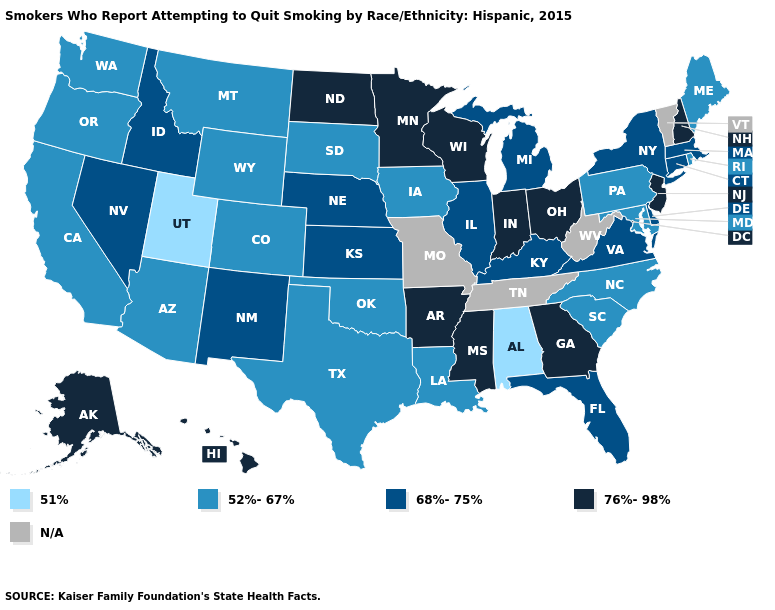What is the lowest value in the USA?
Concise answer only. 51%. What is the lowest value in the MidWest?
Concise answer only. 52%-67%. Does Connecticut have the highest value in the USA?
Quick response, please. No. What is the highest value in the West ?
Give a very brief answer. 76%-98%. What is the value of Rhode Island?
Give a very brief answer. 52%-67%. How many symbols are there in the legend?
Keep it brief. 5. How many symbols are there in the legend?
Short answer required. 5. What is the highest value in the Northeast ?
Be succinct. 76%-98%. What is the value of Arizona?
Give a very brief answer. 52%-67%. Among the states that border Wyoming , which have the highest value?
Answer briefly. Idaho, Nebraska. Does Arkansas have the highest value in the USA?
Concise answer only. Yes. What is the value of Arizona?
Answer briefly. 52%-67%. What is the value of Ohio?
Be succinct. 76%-98%. Name the states that have a value in the range N/A?
Write a very short answer. Missouri, Tennessee, Vermont, West Virginia. What is the lowest value in states that border South Carolina?
Give a very brief answer. 52%-67%. 